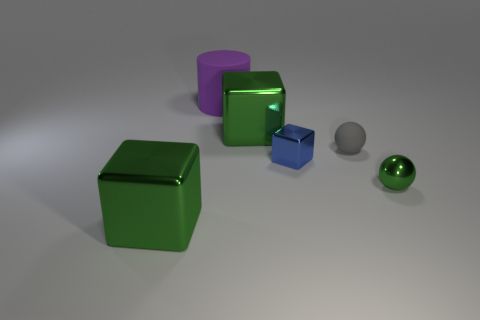The ball that is in front of the small gray object is what color?
Offer a terse response. Green. What number of other objects are there of the same color as the tiny cube?
Your response must be concise. 0. Do the block behind the blue cube and the gray object have the same size?
Your answer should be compact. No. There is a small thing that is right of the gray matte thing; what is its material?
Your answer should be very brief. Metal. Are there any other things that have the same shape as the large purple matte thing?
Offer a terse response. No. How many metal objects are either large cubes or large purple things?
Offer a very short reply. 2. Are there fewer small metal blocks that are behind the big purple thing than large green cubes?
Ensure brevity in your answer.  Yes. There is a big shiny thing that is behind the metal object that is in front of the ball to the right of the small gray sphere; what is its shape?
Offer a very short reply. Cube. Is the number of metal spheres greater than the number of gray matte cubes?
Ensure brevity in your answer.  Yes. What number of other things are there of the same material as the big cylinder
Provide a succinct answer. 1. 